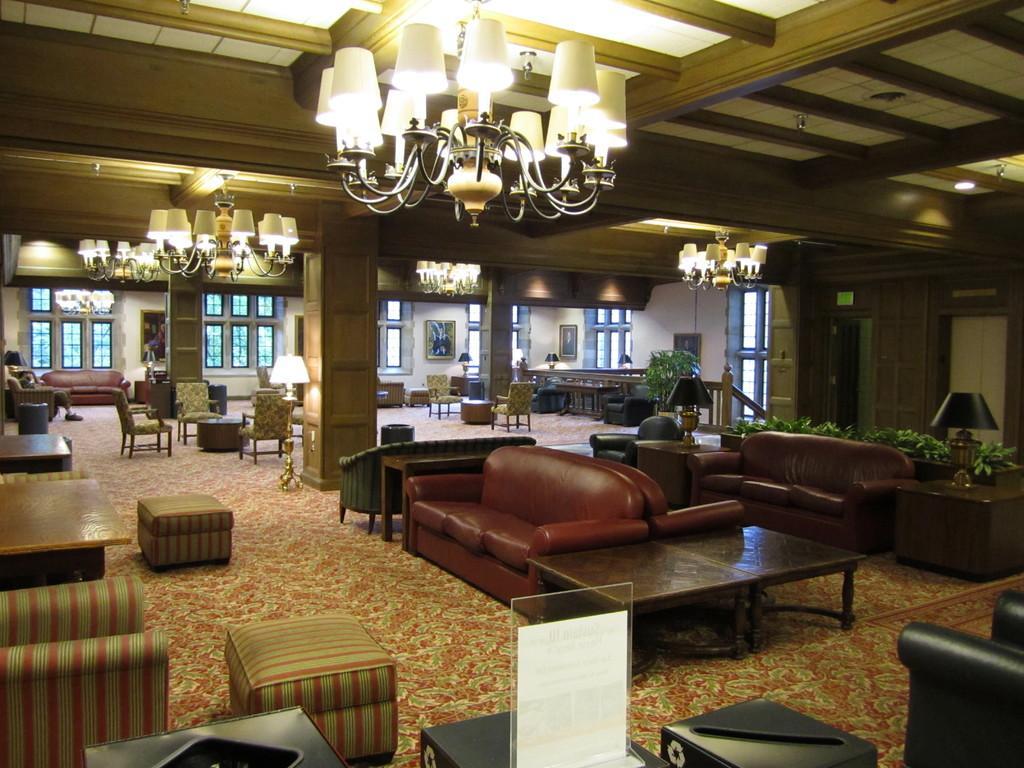Can you describe this image briefly? This image is clicked inside the building. There are many sofas and chairs in this image. In the background, there are windows and wall. At the top, there is a light hanged. 